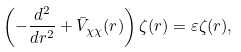<formula> <loc_0><loc_0><loc_500><loc_500>\left ( - \frac { d ^ { 2 } } { d r ^ { 2 } } + \bar { V } _ { \chi \chi } ( r ) \right ) \zeta ( r ) = \varepsilon \zeta ( r ) ,</formula> 